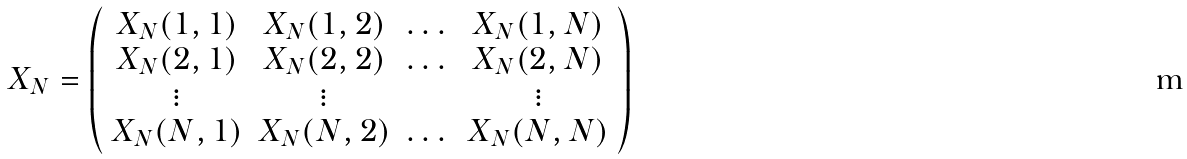Convert formula to latex. <formula><loc_0><loc_0><loc_500><loc_500>X _ { N } = \left ( \begin{array} { c c c c } X _ { N } ( 1 , 1 ) & X _ { N } ( 1 , 2 ) & \dots & X _ { N } ( 1 , N ) \\ X _ { N } ( 2 , 1 ) & X _ { N } ( 2 , 2 ) & \dots & X _ { N } ( 2 , N ) \\ \vdots & \vdots & & \vdots \\ X _ { N } ( N , 1 ) & X _ { N } ( N , 2 ) & \dots & X _ { N } ( N , N ) \end{array} \right )</formula> 